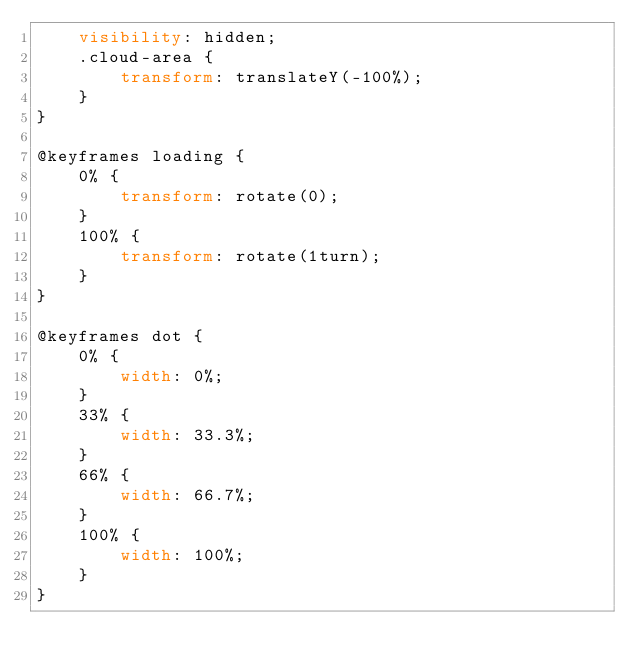Convert code to text. <code><loc_0><loc_0><loc_500><loc_500><_CSS_>    visibility: hidden;
    .cloud-area {
        transform: translateY(-100%);
    }
}

@keyframes loading {
    0% {
        transform: rotate(0);
    }
    100% {
        transform: rotate(1turn);
    }
}

@keyframes dot {
    0% {
        width: 0%;
    }
    33% {
        width: 33.3%;
    }
    66% {
        width: 66.7%;
    }
    100% {
        width: 100%;
    }
}
</code> 